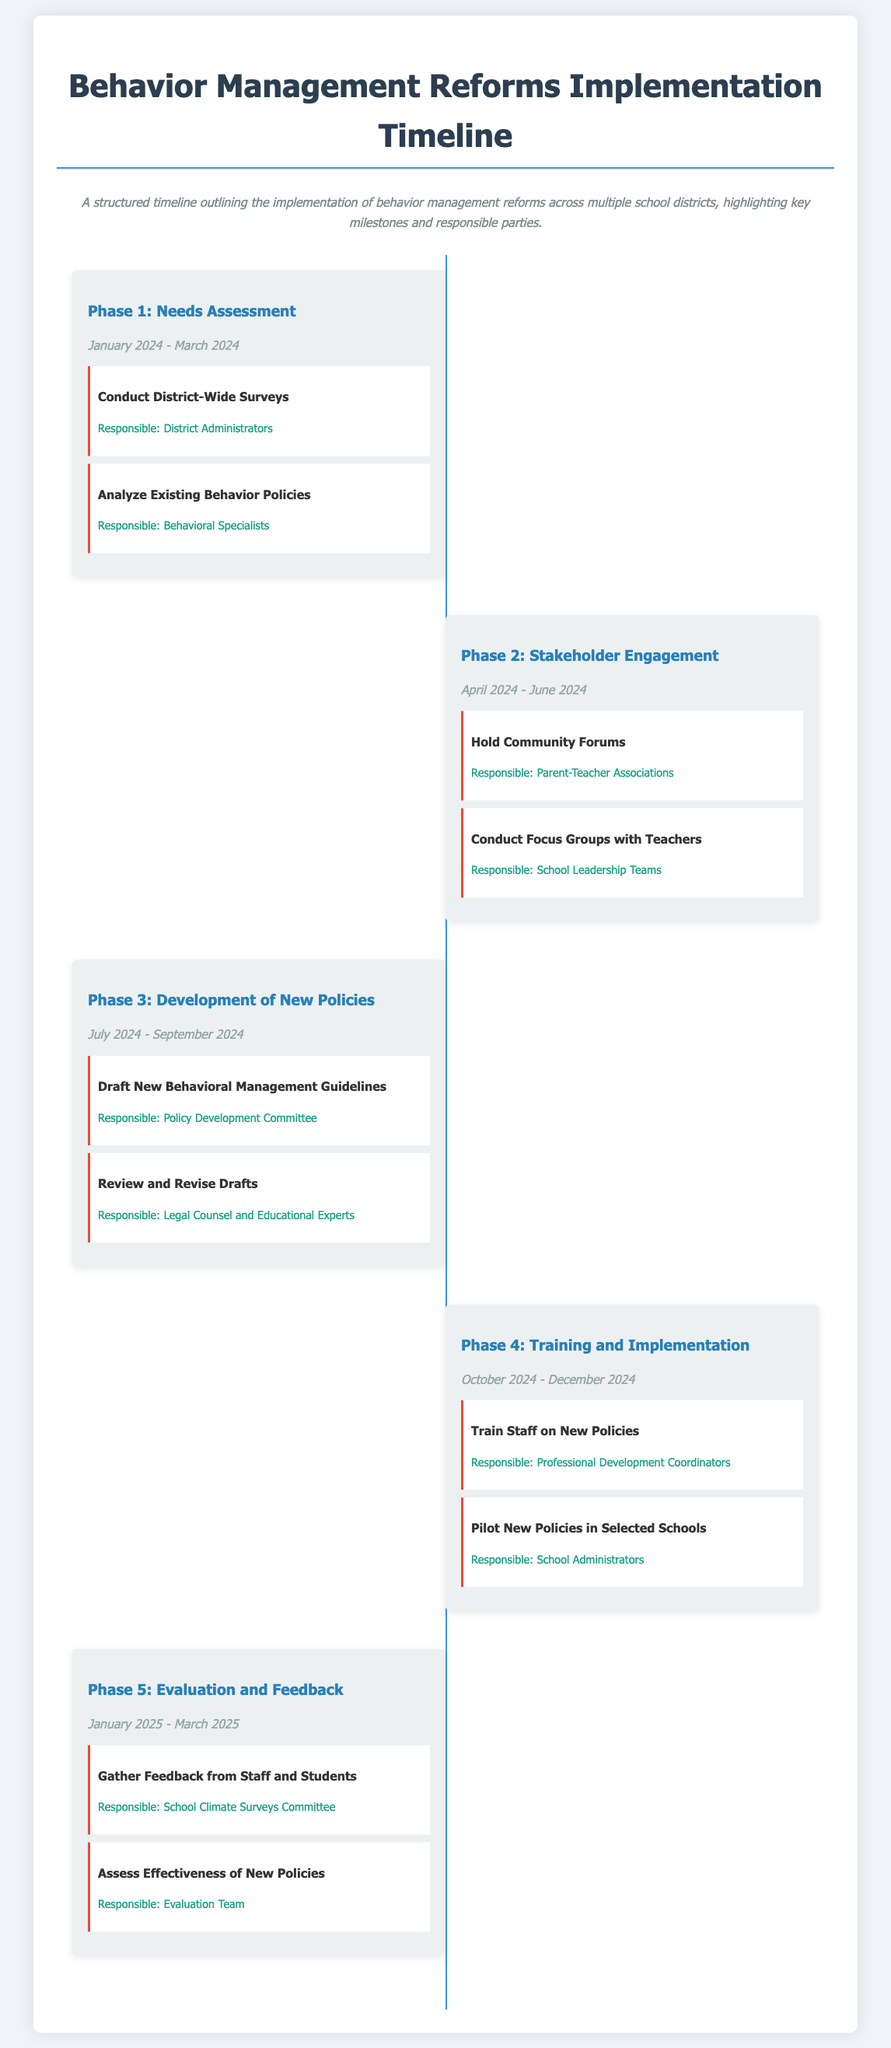What is the duration of Phase 1? The duration of Phase 1 is specified in the document as January 2024 - March 2024.
Answer: January 2024 - March 2024 Who is responsible for conducting district-wide surveys? The document lists District Administrators as the responsible party for this milestone.
Answer: District Administrators What is the title of Phase 3 in the timeline? The title of Phase 3 is mentioned in the document as Development of New Policies.
Answer: Development of New Policies How many key milestones are listed in Phase 4? The document provides two key milestones in Phase 4.
Answer: 2 Which committee is responsible for gathering feedback from staff and students in Phase 5? The School Climate Surveys Committee is identified as responsible in the document.
Answer: School Climate Surveys Committee What phase follows Stakeholder Engagement? The document indicates that Phase 3 follows Stakeholder Engagement.
Answer: Development of New Policies 